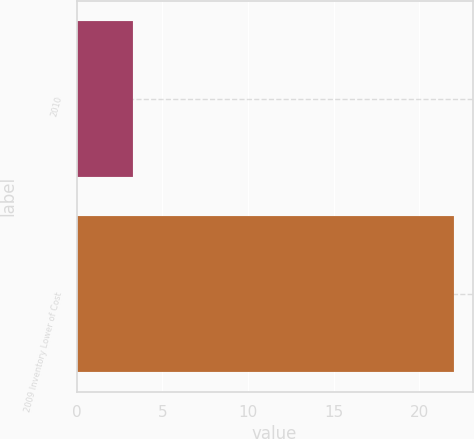Convert chart. <chart><loc_0><loc_0><loc_500><loc_500><bar_chart><fcel>2010<fcel>2009 Inventory Lower of Cost<nl><fcel>3.29<fcel>22<nl></chart> 